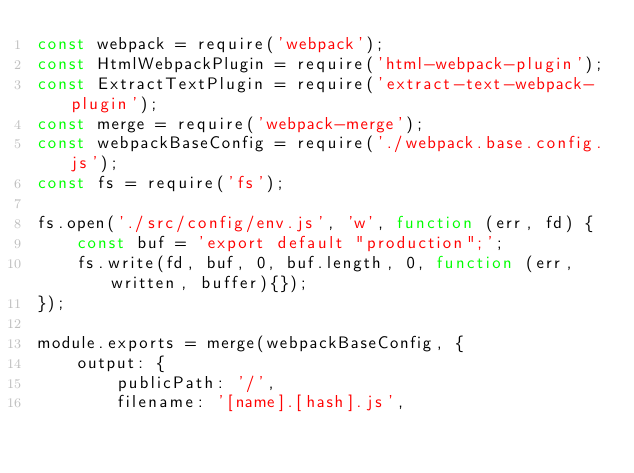<code> <loc_0><loc_0><loc_500><loc_500><_JavaScript_>const webpack = require('webpack');
const HtmlWebpackPlugin = require('html-webpack-plugin');
const ExtractTextPlugin = require('extract-text-webpack-plugin');
const merge = require('webpack-merge');
const webpackBaseConfig = require('./webpack.base.config.js');
const fs = require('fs');

fs.open('./src/config/env.js', 'w', function (err, fd) {
    const buf = 'export default "production";';
    fs.write(fd, buf, 0, buf.length, 0, function (err, written, buffer){});
});

module.exports = merge(webpackBaseConfig, {
    output: {
        publicPath: '/',
        filename: '[name].[hash].js',</code> 